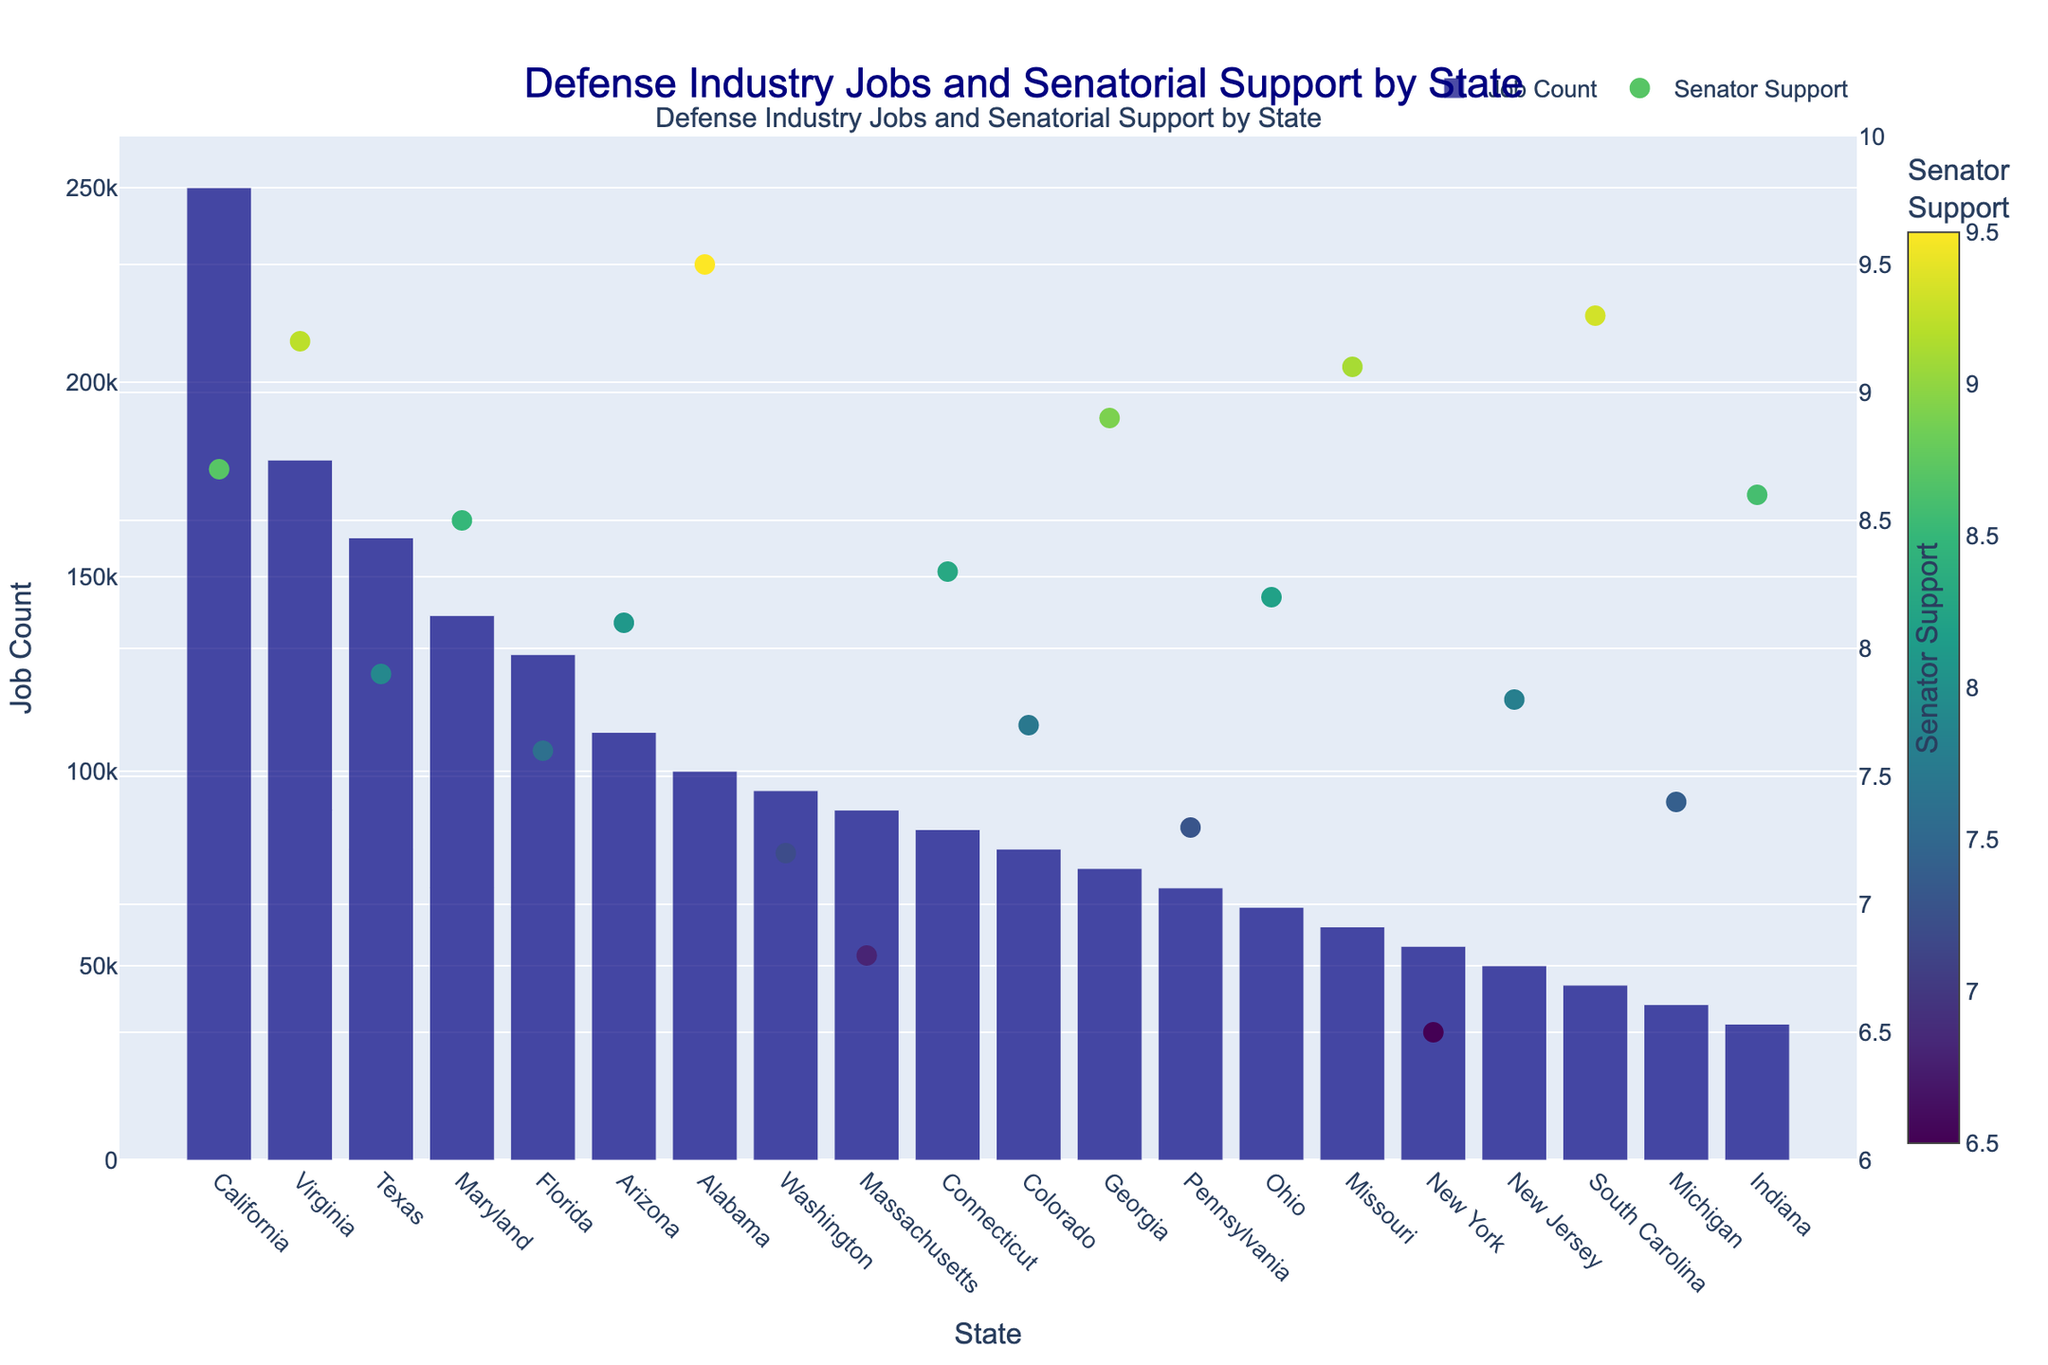What's the title of the plot? The title of the plot is found at the top center of the graph.
Answer: Defense Industry Jobs and Senatorial Support by State Which state has the highest number of defense industry jobs? The highest bar in the plot represents the state with the highest number of jobs.
Answer: California What are the y-axes labels in the plot? There are two y-axes in the plot: the left y-axis is labeled as Job Count, and the right y-axis is labeled as Senator Support.
Answer: Job Count, Senator Support Which state has the lowest senatorial support score? The scatter point with the lowest senatorial support value on the right y-axis identifies the state.
Answer: New York What is the job count for Virginia? The height of the bar for Virginia indicates the job count.
Answer: 180,000 What is the average senatorial support in states with more than 150,000 defense jobs? Identify the senatorial support scores for states with job counts above 150,000 (California, Virginia, Texas), then calculate the average: (8.7 + 9.2 + 7.9)/3.
Answer: 8.6 How does Maryland's senatorial support compare to Colorado's? Locate Maryland and Colorado on the x-axis and compare their respective scatter points.
Answer: Maryland's senatorial support (8.5) is higher than Colorado's (7.7) Which states have both high job counts (above 100,000) and high senatorial support (above 8.5)? Identify states with job counts above 100,000 and visually inspect their senatorial support values: California, Virginia, Alabama, and Georgia fit both criteria.
Answer: California, Virginia, Alabama, Georgia Which state shows a high job count but relatively low senatorial support? Find a state with a high job count bar but a lower senatorial support scatter point, e.g., Texas with a job count of 160,000 and senatorial support of 7.9.
Answer: Texas What is the total number of defense jobs in states with senatorial support above 9.0? Identify states: Virginia, Alabama, Missouri, South Carolina. Sum of job counts: 180,000 + 100,000 + 60,000 + 45,000.
Answer: 385,000 